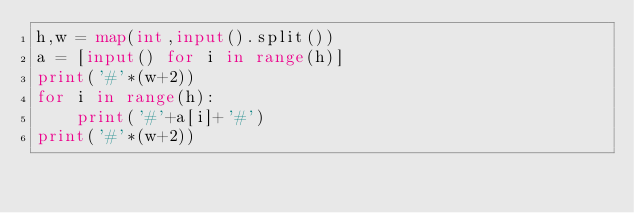Convert code to text. <code><loc_0><loc_0><loc_500><loc_500><_Python_>h,w = map(int,input().split())
a = [input() for i in range(h)]
print('#'*(w+2))
for i in range(h):
    print('#'+a[i]+'#')
print('#'*(w+2))
</code> 